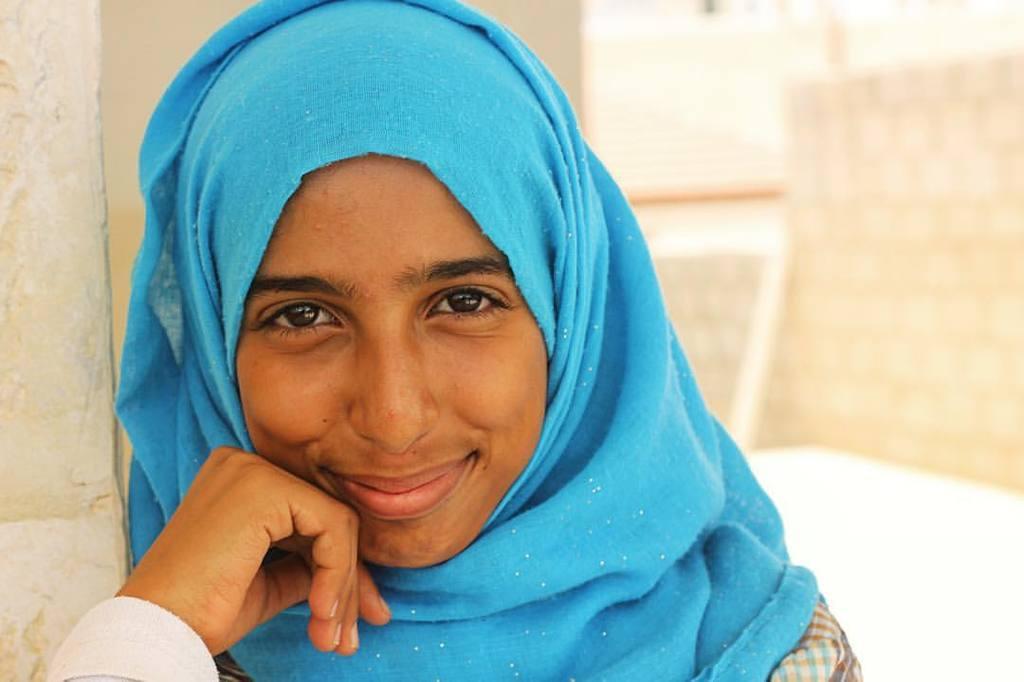Can you describe this image briefly? In this picture there is a girl on the left side of the image. 